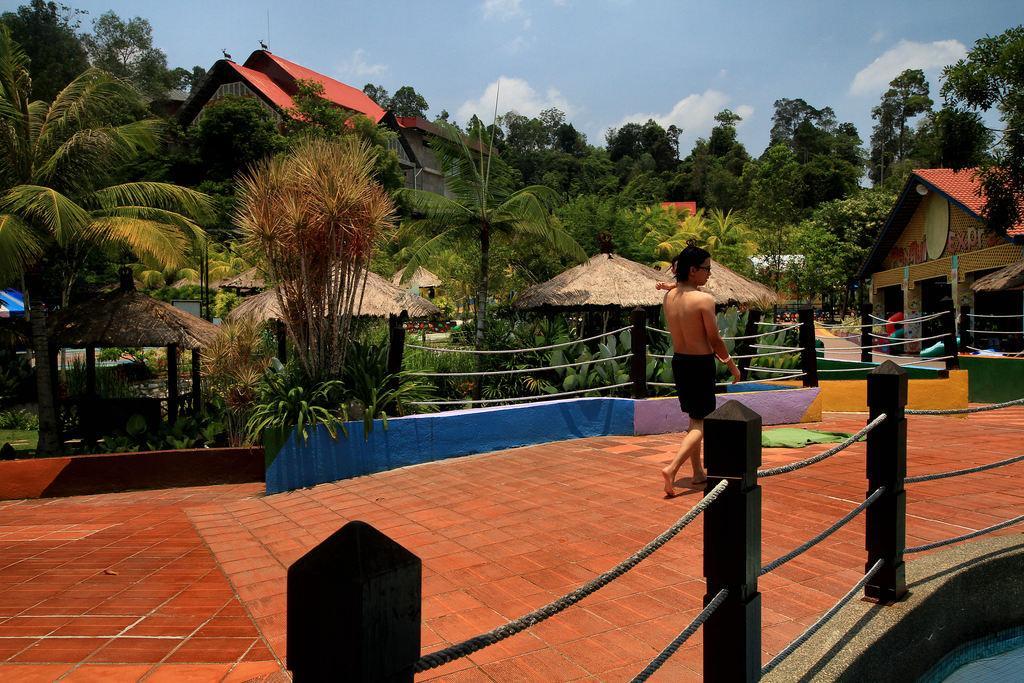In one or two sentences, can you explain what this image depicts? In this image, I can see a person walking on a pathway. At the bottom of the image, I can see the ropes tied to the poles. There are trees, huts, plants and houses. In the background, there is the sky. 